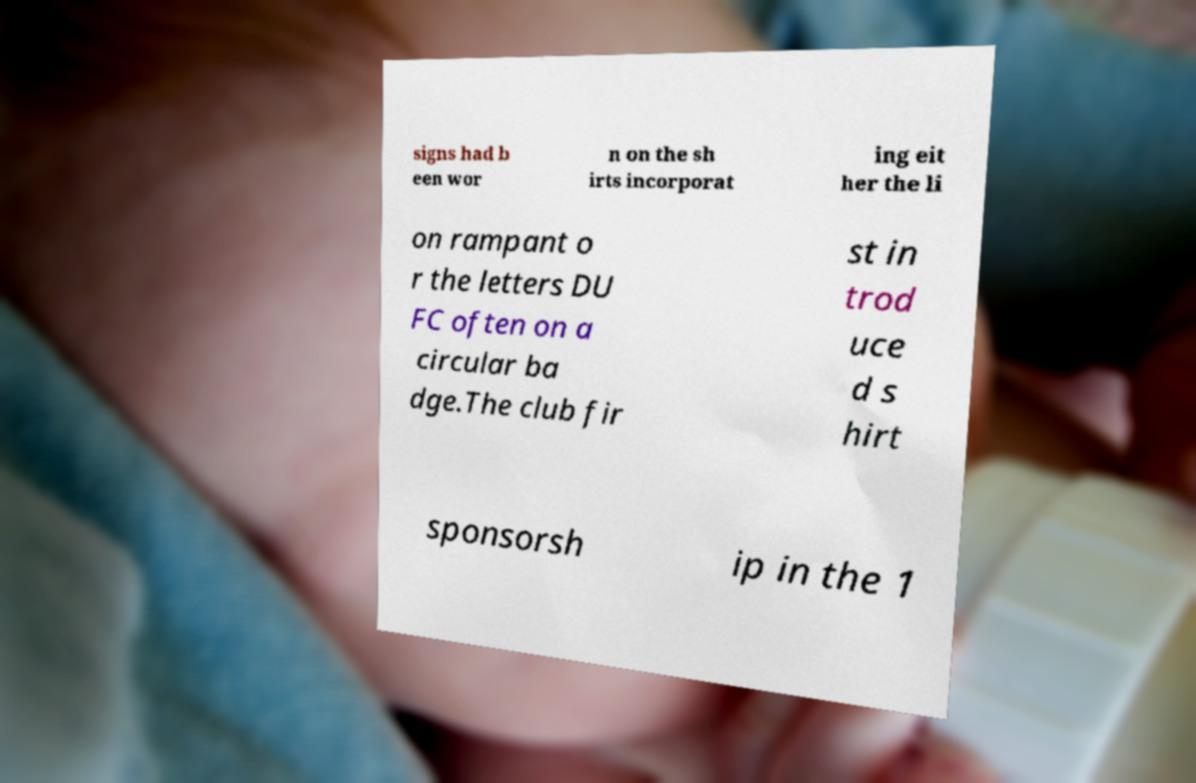I need the written content from this picture converted into text. Can you do that? signs had b een wor n on the sh irts incorporat ing eit her the li on rampant o r the letters DU FC often on a circular ba dge.The club fir st in trod uce d s hirt sponsorsh ip in the 1 